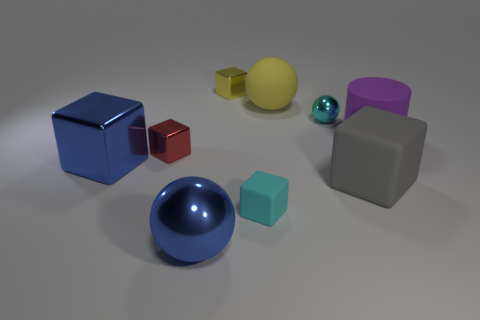Subtract all gray rubber blocks. How many blocks are left? 4 Subtract all cyan balls. How many balls are left? 2 Subtract 3 blocks. How many blocks are left? 2 Subtract all large blue objects. Subtract all large metal blocks. How many objects are left? 6 Add 9 matte balls. How many matte balls are left? 10 Add 2 purple rubber balls. How many purple rubber balls exist? 2 Add 1 yellow metallic blocks. How many objects exist? 10 Subtract 0 blue cylinders. How many objects are left? 9 Subtract all cylinders. How many objects are left? 8 Subtract all yellow blocks. Subtract all yellow spheres. How many blocks are left? 4 